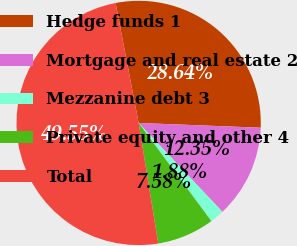Convert chart. <chart><loc_0><loc_0><loc_500><loc_500><pie_chart><fcel>Hedge funds 1<fcel>Mortgage and real estate 2<fcel>Mezzanine debt 3<fcel>Private equity and other 4<fcel>Total<nl><fcel>28.64%<fcel>12.35%<fcel>1.88%<fcel>7.58%<fcel>49.55%<nl></chart> 